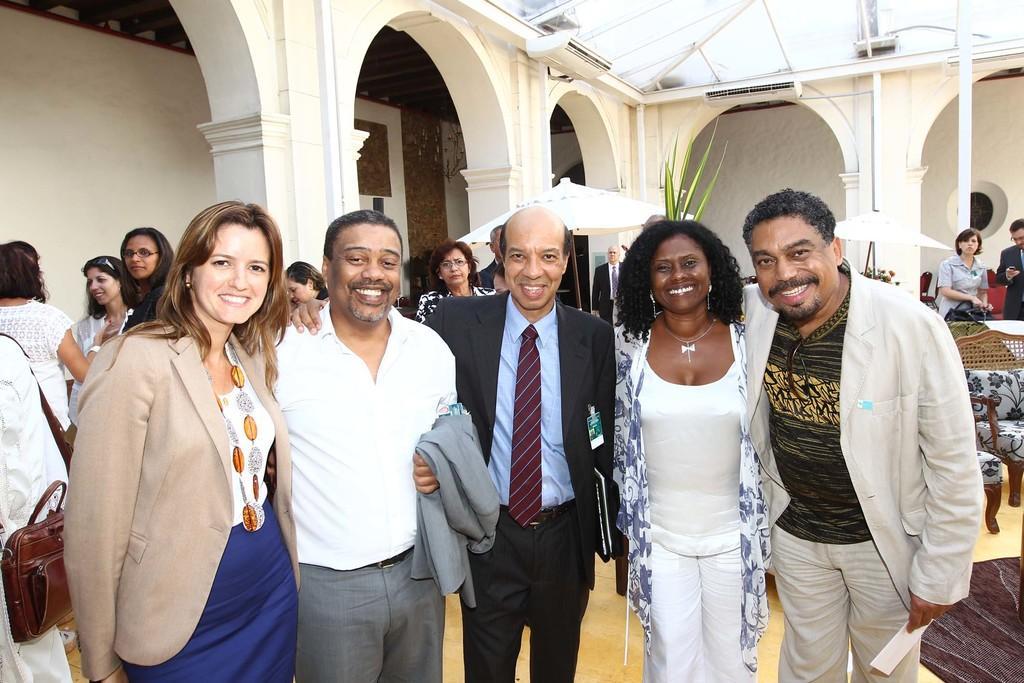In one or two sentences, can you explain what this image depicts? In this image there are a few people standing and posing for the camera with a smile on their face, behind them there are a few other people standing and there are chairs. 